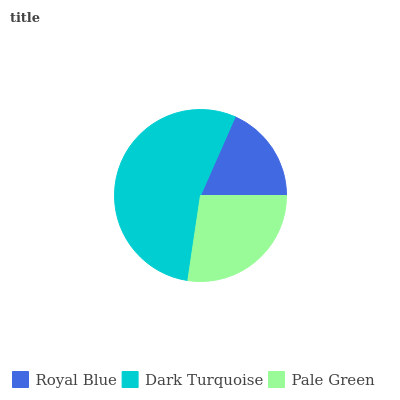Is Royal Blue the minimum?
Answer yes or no. Yes. Is Dark Turquoise the maximum?
Answer yes or no. Yes. Is Pale Green the minimum?
Answer yes or no. No. Is Pale Green the maximum?
Answer yes or no. No. Is Dark Turquoise greater than Pale Green?
Answer yes or no. Yes. Is Pale Green less than Dark Turquoise?
Answer yes or no. Yes. Is Pale Green greater than Dark Turquoise?
Answer yes or no. No. Is Dark Turquoise less than Pale Green?
Answer yes or no. No. Is Pale Green the high median?
Answer yes or no. Yes. Is Pale Green the low median?
Answer yes or no. Yes. Is Dark Turquoise the high median?
Answer yes or no. No. Is Royal Blue the low median?
Answer yes or no. No. 